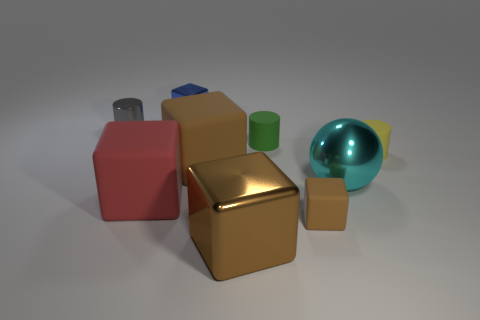There is a small yellow rubber cylinder; are there any red matte blocks behind it? Yes, there is a red matte block directly behind the small yellow cylinder. It's one of the various objects in this collection of geometric shapes where each piece appears to have a distinct texture and color. 